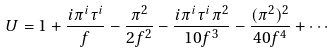Convert formula to latex. <formula><loc_0><loc_0><loc_500><loc_500>U = 1 + \frac { i \pi ^ { i } \tau ^ { i } } { f } - \frac { \pi ^ { 2 } } { 2 f ^ { 2 } } - \frac { i \pi ^ { i } \tau ^ { i } \pi ^ { 2 } } { 1 0 f ^ { 3 } } - \frac { ( \pi ^ { 2 } ) ^ { 2 } } { 4 0 f ^ { 4 } } + \cdots</formula> 